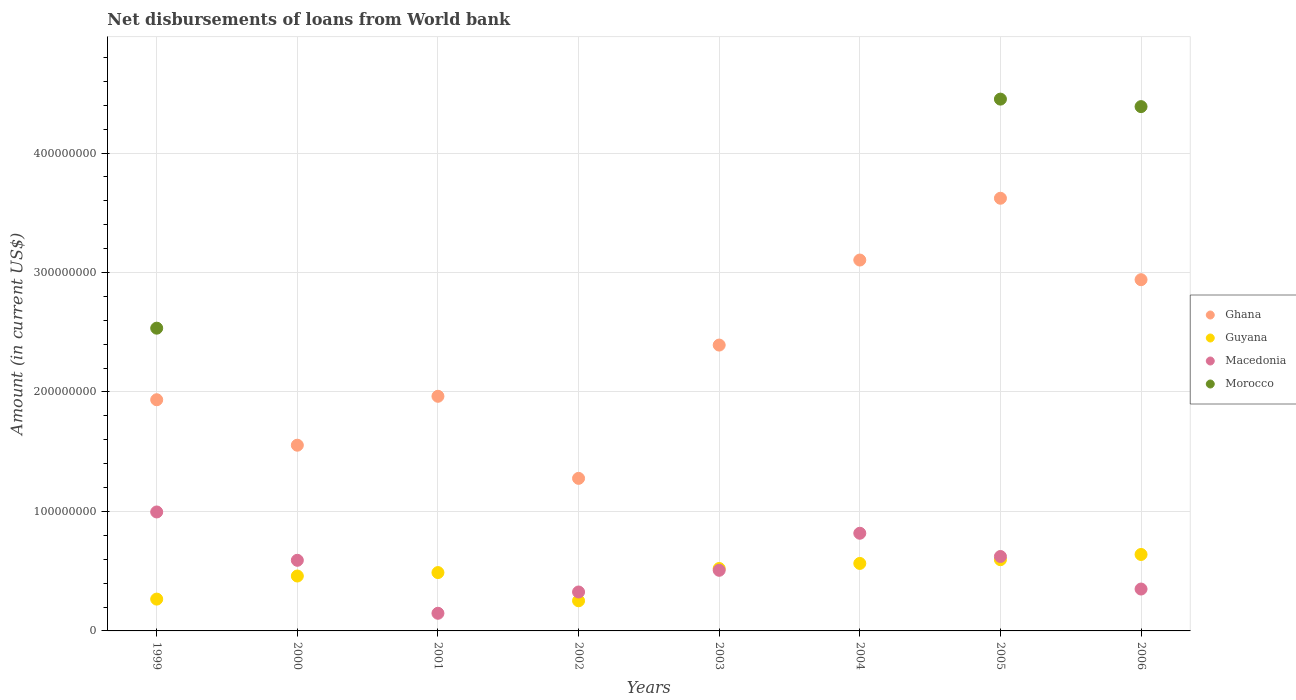How many different coloured dotlines are there?
Keep it short and to the point. 4. Is the number of dotlines equal to the number of legend labels?
Provide a short and direct response. No. What is the amount of loan disbursed from World Bank in Guyana in 2004?
Your answer should be compact. 5.65e+07. Across all years, what is the maximum amount of loan disbursed from World Bank in Morocco?
Give a very brief answer. 4.45e+08. What is the total amount of loan disbursed from World Bank in Morocco in the graph?
Ensure brevity in your answer.  1.14e+09. What is the difference between the amount of loan disbursed from World Bank in Guyana in 2000 and that in 2006?
Keep it short and to the point. -1.80e+07. What is the difference between the amount of loan disbursed from World Bank in Ghana in 2004 and the amount of loan disbursed from World Bank in Guyana in 2003?
Ensure brevity in your answer.  2.58e+08. What is the average amount of loan disbursed from World Bank in Macedonia per year?
Your response must be concise. 5.45e+07. In the year 2000, what is the difference between the amount of loan disbursed from World Bank in Macedonia and amount of loan disbursed from World Bank in Ghana?
Ensure brevity in your answer.  -9.63e+07. In how many years, is the amount of loan disbursed from World Bank in Guyana greater than 120000000 US$?
Keep it short and to the point. 0. What is the ratio of the amount of loan disbursed from World Bank in Guyana in 1999 to that in 2000?
Offer a terse response. 0.58. What is the difference between the highest and the second highest amount of loan disbursed from World Bank in Ghana?
Provide a short and direct response. 5.17e+07. What is the difference between the highest and the lowest amount of loan disbursed from World Bank in Macedonia?
Keep it short and to the point. 8.48e+07. In how many years, is the amount of loan disbursed from World Bank in Morocco greater than the average amount of loan disbursed from World Bank in Morocco taken over all years?
Your answer should be compact. 3. Is it the case that in every year, the sum of the amount of loan disbursed from World Bank in Guyana and amount of loan disbursed from World Bank in Morocco  is greater than the sum of amount of loan disbursed from World Bank in Ghana and amount of loan disbursed from World Bank in Macedonia?
Your answer should be very brief. No. Does the amount of loan disbursed from World Bank in Macedonia monotonically increase over the years?
Give a very brief answer. No. Is the amount of loan disbursed from World Bank in Ghana strictly less than the amount of loan disbursed from World Bank in Guyana over the years?
Your answer should be very brief. No. How many dotlines are there?
Offer a very short reply. 4. How many years are there in the graph?
Offer a terse response. 8. Does the graph contain grids?
Your answer should be very brief. Yes. Where does the legend appear in the graph?
Give a very brief answer. Center right. How many legend labels are there?
Offer a terse response. 4. How are the legend labels stacked?
Provide a short and direct response. Vertical. What is the title of the graph?
Your answer should be very brief. Net disbursements of loans from World bank. Does "Cote d'Ivoire" appear as one of the legend labels in the graph?
Give a very brief answer. No. What is the label or title of the Y-axis?
Your answer should be compact. Amount (in current US$). What is the Amount (in current US$) in Ghana in 1999?
Your response must be concise. 1.94e+08. What is the Amount (in current US$) in Guyana in 1999?
Your response must be concise. 2.66e+07. What is the Amount (in current US$) of Macedonia in 1999?
Ensure brevity in your answer.  9.96e+07. What is the Amount (in current US$) in Morocco in 1999?
Provide a succinct answer. 2.53e+08. What is the Amount (in current US$) of Ghana in 2000?
Give a very brief answer. 1.55e+08. What is the Amount (in current US$) of Guyana in 2000?
Provide a succinct answer. 4.60e+07. What is the Amount (in current US$) of Macedonia in 2000?
Keep it short and to the point. 5.91e+07. What is the Amount (in current US$) of Morocco in 2000?
Your response must be concise. 0. What is the Amount (in current US$) in Ghana in 2001?
Ensure brevity in your answer.  1.96e+08. What is the Amount (in current US$) of Guyana in 2001?
Make the answer very short. 4.88e+07. What is the Amount (in current US$) of Macedonia in 2001?
Your response must be concise. 1.48e+07. What is the Amount (in current US$) of Morocco in 2001?
Keep it short and to the point. 0. What is the Amount (in current US$) of Ghana in 2002?
Give a very brief answer. 1.28e+08. What is the Amount (in current US$) in Guyana in 2002?
Your answer should be compact. 2.52e+07. What is the Amount (in current US$) in Macedonia in 2002?
Your response must be concise. 3.26e+07. What is the Amount (in current US$) in Ghana in 2003?
Offer a terse response. 2.39e+08. What is the Amount (in current US$) of Guyana in 2003?
Provide a short and direct response. 5.22e+07. What is the Amount (in current US$) in Macedonia in 2003?
Your response must be concise. 5.07e+07. What is the Amount (in current US$) of Morocco in 2003?
Your answer should be very brief. 0. What is the Amount (in current US$) in Ghana in 2004?
Ensure brevity in your answer.  3.10e+08. What is the Amount (in current US$) in Guyana in 2004?
Offer a very short reply. 5.65e+07. What is the Amount (in current US$) in Macedonia in 2004?
Make the answer very short. 8.18e+07. What is the Amount (in current US$) of Ghana in 2005?
Provide a short and direct response. 3.62e+08. What is the Amount (in current US$) of Guyana in 2005?
Your answer should be very brief. 5.96e+07. What is the Amount (in current US$) in Macedonia in 2005?
Offer a very short reply. 6.23e+07. What is the Amount (in current US$) in Morocco in 2005?
Provide a short and direct response. 4.45e+08. What is the Amount (in current US$) in Ghana in 2006?
Your answer should be compact. 2.94e+08. What is the Amount (in current US$) in Guyana in 2006?
Your answer should be very brief. 6.40e+07. What is the Amount (in current US$) in Macedonia in 2006?
Make the answer very short. 3.51e+07. What is the Amount (in current US$) in Morocco in 2006?
Offer a very short reply. 4.39e+08. Across all years, what is the maximum Amount (in current US$) of Ghana?
Keep it short and to the point. 3.62e+08. Across all years, what is the maximum Amount (in current US$) of Guyana?
Offer a terse response. 6.40e+07. Across all years, what is the maximum Amount (in current US$) in Macedonia?
Offer a terse response. 9.96e+07. Across all years, what is the maximum Amount (in current US$) of Morocco?
Keep it short and to the point. 4.45e+08. Across all years, what is the minimum Amount (in current US$) in Ghana?
Offer a terse response. 1.28e+08. Across all years, what is the minimum Amount (in current US$) of Guyana?
Provide a succinct answer. 2.52e+07. Across all years, what is the minimum Amount (in current US$) in Macedonia?
Give a very brief answer. 1.48e+07. What is the total Amount (in current US$) of Ghana in the graph?
Your answer should be compact. 1.88e+09. What is the total Amount (in current US$) of Guyana in the graph?
Make the answer very short. 3.79e+08. What is the total Amount (in current US$) of Macedonia in the graph?
Your answer should be very brief. 4.36e+08. What is the total Amount (in current US$) in Morocco in the graph?
Give a very brief answer. 1.14e+09. What is the difference between the Amount (in current US$) of Ghana in 1999 and that in 2000?
Your answer should be very brief. 3.81e+07. What is the difference between the Amount (in current US$) of Guyana in 1999 and that in 2000?
Your answer should be compact. -1.93e+07. What is the difference between the Amount (in current US$) in Macedonia in 1999 and that in 2000?
Offer a terse response. 4.05e+07. What is the difference between the Amount (in current US$) in Ghana in 1999 and that in 2001?
Offer a terse response. -2.90e+06. What is the difference between the Amount (in current US$) of Guyana in 1999 and that in 2001?
Make the answer very short. -2.22e+07. What is the difference between the Amount (in current US$) of Macedonia in 1999 and that in 2001?
Give a very brief answer. 8.48e+07. What is the difference between the Amount (in current US$) in Ghana in 1999 and that in 2002?
Provide a succinct answer. 6.58e+07. What is the difference between the Amount (in current US$) in Guyana in 1999 and that in 2002?
Provide a short and direct response. 1.40e+06. What is the difference between the Amount (in current US$) in Macedonia in 1999 and that in 2002?
Provide a succinct answer. 6.70e+07. What is the difference between the Amount (in current US$) of Ghana in 1999 and that in 2003?
Make the answer very short. -4.58e+07. What is the difference between the Amount (in current US$) of Guyana in 1999 and that in 2003?
Give a very brief answer. -2.56e+07. What is the difference between the Amount (in current US$) of Macedonia in 1999 and that in 2003?
Your answer should be very brief. 4.88e+07. What is the difference between the Amount (in current US$) of Ghana in 1999 and that in 2004?
Make the answer very short. -1.17e+08. What is the difference between the Amount (in current US$) of Guyana in 1999 and that in 2004?
Offer a terse response. -2.99e+07. What is the difference between the Amount (in current US$) of Macedonia in 1999 and that in 2004?
Your answer should be very brief. 1.78e+07. What is the difference between the Amount (in current US$) in Ghana in 1999 and that in 2005?
Offer a very short reply. -1.69e+08. What is the difference between the Amount (in current US$) in Guyana in 1999 and that in 2005?
Give a very brief answer. -3.30e+07. What is the difference between the Amount (in current US$) in Macedonia in 1999 and that in 2005?
Your answer should be compact. 3.73e+07. What is the difference between the Amount (in current US$) of Morocco in 1999 and that in 2005?
Your answer should be very brief. -1.92e+08. What is the difference between the Amount (in current US$) of Ghana in 1999 and that in 2006?
Make the answer very short. -1.00e+08. What is the difference between the Amount (in current US$) in Guyana in 1999 and that in 2006?
Make the answer very short. -3.74e+07. What is the difference between the Amount (in current US$) of Macedonia in 1999 and that in 2006?
Ensure brevity in your answer.  6.45e+07. What is the difference between the Amount (in current US$) of Morocco in 1999 and that in 2006?
Ensure brevity in your answer.  -1.85e+08. What is the difference between the Amount (in current US$) in Ghana in 2000 and that in 2001?
Offer a very short reply. -4.09e+07. What is the difference between the Amount (in current US$) of Guyana in 2000 and that in 2001?
Make the answer very short. -2.88e+06. What is the difference between the Amount (in current US$) in Macedonia in 2000 and that in 2001?
Your response must be concise. 4.43e+07. What is the difference between the Amount (in current US$) in Ghana in 2000 and that in 2002?
Make the answer very short. 2.78e+07. What is the difference between the Amount (in current US$) in Guyana in 2000 and that in 2002?
Offer a very short reply. 2.07e+07. What is the difference between the Amount (in current US$) in Macedonia in 2000 and that in 2002?
Give a very brief answer. 2.65e+07. What is the difference between the Amount (in current US$) in Ghana in 2000 and that in 2003?
Ensure brevity in your answer.  -8.38e+07. What is the difference between the Amount (in current US$) of Guyana in 2000 and that in 2003?
Make the answer very short. -6.29e+06. What is the difference between the Amount (in current US$) of Macedonia in 2000 and that in 2003?
Offer a very short reply. 8.37e+06. What is the difference between the Amount (in current US$) of Ghana in 2000 and that in 2004?
Ensure brevity in your answer.  -1.55e+08. What is the difference between the Amount (in current US$) in Guyana in 2000 and that in 2004?
Give a very brief answer. -1.05e+07. What is the difference between the Amount (in current US$) in Macedonia in 2000 and that in 2004?
Offer a terse response. -2.26e+07. What is the difference between the Amount (in current US$) in Ghana in 2000 and that in 2005?
Give a very brief answer. -2.07e+08. What is the difference between the Amount (in current US$) of Guyana in 2000 and that in 2005?
Your response must be concise. -1.37e+07. What is the difference between the Amount (in current US$) of Macedonia in 2000 and that in 2005?
Your answer should be very brief. -3.19e+06. What is the difference between the Amount (in current US$) in Ghana in 2000 and that in 2006?
Give a very brief answer. -1.39e+08. What is the difference between the Amount (in current US$) of Guyana in 2000 and that in 2006?
Make the answer very short. -1.80e+07. What is the difference between the Amount (in current US$) in Macedonia in 2000 and that in 2006?
Your answer should be compact. 2.41e+07. What is the difference between the Amount (in current US$) in Ghana in 2001 and that in 2002?
Provide a short and direct response. 6.87e+07. What is the difference between the Amount (in current US$) of Guyana in 2001 and that in 2002?
Make the answer very short. 2.36e+07. What is the difference between the Amount (in current US$) in Macedonia in 2001 and that in 2002?
Offer a very short reply. -1.78e+07. What is the difference between the Amount (in current US$) of Ghana in 2001 and that in 2003?
Keep it short and to the point. -4.29e+07. What is the difference between the Amount (in current US$) in Guyana in 2001 and that in 2003?
Your answer should be compact. -3.41e+06. What is the difference between the Amount (in current US$) in Macedonia in 2001 and that in 2003?
Your answer should be compact. -3.60e+07. What is the difference between the Amount (in current US$) of Ghana in 2001 and that in 2004?
Ensure brevity in your answer.  -1.14e+08. What is the difference between the Amount (in current US$) in Guyana in 2001 and that in 2004?
Offer a terse response. -7.65e+06. What is the difference between the Amount (in current US$) in Macedonia in 2001 and that in 2004?
Provide a short and direct response. -6.70e+07. What is the difference between the Amount (in current US$) of Ghana in 2001 and that in 2005?
Your answer should be very brief. -1.66e+08. What is the difference between the Amount (in current US$) of Guyana in 2001 and that in 2005?
Give a very brief answer. -1.08e+07. What is the difference between the Amount (in current US$) in Macedonia in 2001 and that in 2005?
Keep it short and to the point. -4.75e+07. What is the difference between the Amount (in current US$) of Ghana in 2001 and that in 2006?
Offer a very short reply. -9.76e+07. What is the difference between the Amount (in current US$) in Guyana in 2001 and that in 2006?
Your response must be concise. -1.52e+07. What is the difference between the Amount (in current US$) of Macedonia in 2001 and that in 2006?
Your answer should be compact. -2.03e+07. What is the difference between the Amount (in current US$) in Ghana in 2002 and that in 2003?
Offer a very short reply. -1.12e+08. What is the difference between the Amount (in current US$) in Guyana in 2002 and that in 2003?
Give a very brief answer. -2.70e+07. What is the difference between the Amount (in current US$) in Macedonia in 2002 and that in 2003?
Your answer should be compact. -1.82e+07. What is the difference between the Amount (in current US$) in Ghana in 2002 and that in 2004?
Make the answer very short. -1.83e+08. What is the difference between the Amount (in current US$) of Guyana in 2002 and that in 2004?
Give a very brief answer. -3.13e+07. What is the difference between the Amount (in current US$) in Macedonia in 2002 and that in 2004?
Ensure brevity in your answer.  -4.92e+07. What is the difference between the Amount (in current US$) in Ghana in 2002 and that in 2005?
Your answer should be compact. -2.34e+08. What is the difference between the Amount (in current US$) in Guyana in 2002 and that in 2005?
Provide a succinct answer. -3.44e+07. What is the difference between the Amount (in current US$) in Macedonia in 2002 and that in 2005?
Provide a short and direct response. -2.97e+07. What is the difference between the Amount (in current US$) in Ghana in 2002 and that in 2006?
Your answer should be compact. -1.66e+08. What is the difference between the Amount (in current US$) of Guyana in 2002 and that in 2006?
Your response must be concise. -3.88e+07. What is the difference between the Amount (in current US$) in Macedonia in 2002 and that in 2006?
Make the answer very short. -2.47e+06. What is the difference between the Amount (in current US$) of Ghana in 2003 and that in 2004?
Provide a short and direct response. -7.12e+07. What is the difference between the Amount (in current US$) in Guyana in 2003 and that in 2004?
Your answer should be very brief. -4.25e+06. What is the difference between the Amount (in current US$) of Macedonia in 2003 and that in 2004?
Provide a succinct answer. -3.10e+07. What is the difference between the Amount (in current US$) in Ghana in 2003 and that in 2005?
Keep it short and to the point. -1.23e+08. What is the difference between the Amount (in current US$) in Guyana in 2003 and that in 2005?
Ensure brevity in your answer.  -7.37e+06. What is the difference between the Amount (in current US$) in Macedonia in 2003 and that in 2005?
Offer a terse response. -1.16e+07. What is the difference between the Amount (in current US$) in Ghana in 2003 and that in 2006?
Ensure brevity in your answer.  -5.47e+07. What is the difference between the Amount (in current US$) of Guyana in 2003 and that in 2006?
Provide a succinct answer. -1.17e+07. What is the difference between the Amount (in current US$) in Macedonia in 2003 and that in 2006?
Your answer should be compact. 1.57e+07. What is the difference between the Amount (in current US$) of Ghana in 2004 and that in 2005?
Your response must be concise. -5.17e+07. What is the difference between the Amount (in current US$) in Guyana in 2004 and that in 2005?
Offer a very short reply. -3.12e+06. What is the difference between the Amount (in current US$) of Macedonia in 2004 and that in 2005?
Provide a short and direct response. 1.94e+07. What is the difference between the Amount (in current US$) in Ghana in 2004 and that in 2006?
Give a very brief answer. 1.64e+07. What is the difference between the Amount (in current US$) of Guyana in 2004 and that in 2006?
Give a very brief answer. -7.50e+06. What is the difference between the Amount (in current US$) in Macedonia in 2004 and that in 2006?
Ensure brevity in your answer.  4.67e+07. What is the difference between the Amount (in current US$) in Ghana in 2005 and that in 2006?
Provide a short and direct response. 6.82e+07. What is the difference between the Amount (in current US$) of Guyana in 2005 and that in 2006?
Keep it short and to the point. -4.38e+06. What is the difference between the Amount (in current US$) in Macedonia in 2005 and that in 2006?
Keep it short and to the point. 2.72e+07. What is the difference between the Amount (in current US$) of Morocco in 2005 and that in 2006?
Offer a terse response. 6.27e+06. What is the difference between the Amount (in current US$) of Ghana in 1999 and the Amount (in current US$) of Guyana in 2000?
Your answer should be compact. 1.48e+08. What is the difference between the Amount (in current US$) of Ghana in 1999 and the Amount (in current US$) of Macedonia in 2000?
Give a very brief answer. 1.34e+08. What is the difference between the Amount (in current US$) in Guyana in 1999 and the Amount (in current US$) in Macedonia in 2000?
Give a very brief answer. -3.25e+07. What is the difference between the Amount (in current US$) of Ghana in 1999 and the Amount (in current US$) of Guyana in 2001?
Your answer should be very brief. 1.45e+08. What is the difference between the Amount (in current US$) in Ghana in 1999 and the Amount (in current US$) in Macedonia in 2001?
Your answer should be very brief. 1.79e+08. What is the difference between the Amount (in current US$) of Guyana in 1999 and the Amount (in current US$) of Macedonia in 2001?
Offer a terse response. 1.19e+07. What is the difference between the Amount (in current US$) of Ghana in 1999 and the Amount (in current US$) of Guyana in 2002?
Make the answer very short. 1.68e+08. What is the difference between the Amount (in current US$) of Ghana in 1999 and the Amount (in current US$) of Macedonia in 2002?
Your answer should be compact. 1.61e+08. What is the difference between the Amount (in current US$) of Guyana in 1999 and the Amount (in current US$) of Macedonia in 2002?
Your response must be concise. -5.96e+06. What is the difference between the Amount (in current US$) in Ghana in 1999 and the Amount (in current US$) in Guyana in 2003?
Provide a succinct answer. 1.41e+08. What is the difference between the Amount (in current US$) of Ghana in 1999 and the Amount (in current US$) of Macedonia in 2003?
Provide a succinct answer. 1.43e+08. What is the difference between the Amount (in current US$) in Guyana in 1999 and the Amount (in current US$) in Macedonia in 2003?
Give a very brief answer. -2.41e+07. What is the difference between the Amount (in current US$) of Ghana in 1999 and the Amount (in current US$) of Guyana in 2004?
Provide a succinct answer. 1.37e+08. What is the difference between the Amount (in current US$) of Ghana in 1999 and the Amount (in current US$) of Macedonia in 2004?
Make the answer very short. 1.12e+08. What is the difference between the Amount (in current US$) in Guyana in 1999 and the Amount (in current US$) in Macedonia in 2004?
Provide a succinct answer. -5.51e+07. What is the difference between the Amount (in current US$) of Ghana in 1999 and the Amount (in current US$) of Guyana in 2005?
Provide a succinct answer. 1.34e+08. What is the difference between the Amount (in current US$) of Ghana in 1999 and the Amount (in current US$) of Macedonia in 2005?
Ensure brevity in your answer.  1.31e+08. What is the difference between the Amount (in current US$) of Ghana in 1999 and the Amount (in current US$) of Morocco in 2005?
Provide a succinct answer. -2.52e+08. What is the difference between the Amount (in current US$) of Guyana in 1999 and the Amount (in current US$) of Macedonia in 2005?
Ensure brevity in your answer.  -3.57e+07. What is the difference between the Amount (in current US$) of Guyana in 1999 and the Amount (in current US$) of Morocco in 2005?
Ensure brevity in your answer.  -4.19e+08. What is the difference between the Amount (in current US$) in Macedonia in 1999 and the Amount (in current US$) in Morocco in 2005?
Keep it short and to the point. -3.46e+08. What is the difference between the Amount (in current US$) of Ghana in 1999 and the Amount (in current US$) of Guyana in 2006?
Your answer should be compact. 1.30e+08. What is the difference between the Amount (in current US$) in Ghana in 1999 and the Amount (in current US$) in Macedonia in 2006?
Ensure brevity in your answer.  1.58e+08. What is the difference between the Amount (in current US$) of Ghana in 1999 and the Amount (in current US$) of Morocco in 2006?
Your answer should be compact. -2.45e+08. What is the difference between the Amount (in current US$) in Guyana in 1999 and the Amount (in current US$) in Macedonia in 2006?
Give a very brief answer. -8.43e+06. What is the difference between the Amount (in current US$) in Guyana in 1999 and the Amount (in current US$) in Morocco in 2006?
Your answer should be very brief. -4.12e+08. What is the difference between the Amount (in current US$) of Macedonia in 1999 and the Amount (in current US$) of Morocco in 2006?
Make the answer very short. -3.39e+08. What is the difference between the Amount (in current US$) in Ghana in 2000 and the Amount (in current US$) in Guyana in 2001?
Provide a short and direct response. 1.07e+08. What is the difference between the Amount (in current US$) in Ghana in 2000 and the Amount (in current US$) in Macedonia in 2001?
Keep it short and to the point. 1.41e+08. What is the difference between the Amount (in current US$) in Guyana in 2000 and the Amount (in current US$) in Macedonia in 2001?
Provide a succinct answer. 3.12e+07. What is the difference between the Amount (in current US$) in Ghana in 2000 and the Amount (in current US$) in Guyana in 2002?
Your answer should be compact. 1.30e+08. What is the difference between the Amount (in current US$) of Ghana in 2000 and the Amount (in current US$) of Macedonia in 2002?
Make the answer very short. 1.23e+08. What is the difference between the Amount (in current US$) of Guyana in 2000 and the Amount (in current US$) of Macedonia in 2002?
Keep it short and to the point. 1.34e+07. What is the difference between the Amount (in current US$) of Ghana in 2000 and the Amount (in current US$) of Guyana in 2003?
Offer a very short reply. 1.03e+08. What is the difference between the Amount (in current US$) of Ghana in 2000 and the Amount (in current US$) of Macedonia in 2003?
Your answer should be very brief. 1.05e+08. What is the difference between the Amount (in current US$) in Guyana in 2000 and the Amount (in current US$) in Macedonia in 2003?
Your answer should be compact. -4.79e+06. What is the difference between the Amount (in current US$) of Ghana in 2000 and the Amount (in current US$) of Guyana in 2004?
Offer a terse response. 9.90e+07. What is the difference between the Amount (in current US$) of Ghana in 2000 and the Amount (in current US$) of Macedonia in 2004?
Give a very brief answer. 7.37e+07. What is the difference between the Amount (in current US$) in Guyana in 2000 and the Amount (in current US$) in Macedonia in 2004?
Make the answer very short. -3.58e+07. What is the difference between the Amount (in current US$) in Ghana in 2000 and the Amount (in current US$) in Guyana in 2005?
Your answer should be very brief. 9.58e+07. What is the difference between the Amount (in current US$) of Ghana in 2000 and the Amount (in current US$) of Macedonia in 2005?
Offer a very short reply. 9.32e+07. What is the difference between the Amount (in current US$) of Ghana in 2000 and the Amount (in current US$) of Morocco in 2005?
Offer a very short reply. -2.90e+08. What is the difference between the Amount (in current US$) in Guyana in 2000 and the Amount (in current US$) in Macedonia in 2005?
Your response must be concise. -1.63e+07. What is the difference between the Amount (in current US$) of Guyana in 2000 and the Amount (in current US$) of Morocco in 2005?
Offer a very short reply. -3.99e+08. What is the difference between the Amount (in current US$) of Macedonia in 2000 and the Amount (in current US$) of Morocco in 2005?
Your answer should be very brief. -3.86e+08. What is the difference between the Amount (in current US$) in Ghana in 2000 and the Amount (in current US$) in Guyana in 2006?
Your answer should be compact. 9.15e+07. What is the difference between the Amount (in current US$) in Ghana in 2000 and the Amount (in current US$) in Macedonia in 2006?
Give a very brief answer. 1.20e+08. What is the difference between the Amount (in current US$) of Ghana in 2000 and the Amount (in current US$) of Morocco in 2006?
Keep it short and to the point. -2.83e+08. What is the difference between the Amount (in current US$) in Guyana in 2000 and the Amount (in current US$) in Macedonia in 2006?
Keep it short and to the point. 1.09e+07. What is the difference between the Amount (in current US$) in Guyana in 2000 and the Amount (in current US$) in Morocco in 2006?
Your response must be concise. -3.93e+08. What is the difference between the Amount (in current US$) in Macedonia in 2000 and the Amount (in current US$) in Morocco in 2006?
Your answer should be very brief. -3.80e+08. What is the difference between the Amount (in current US$) of Ghana in 2001 and the Amount (in current US$) of Guyana in 2002?
Your answer should be very brief. 1.71e+08. What is the difference between the Amount (in current US$) of Ghana in 2001 and the Amount (in current US$) of Macedonia in 2002?
Your answer should be very brief. 1.64e+08. What is the difference between the Amount (in current US$) of Guyana in 2001 and the Amount (in current US$) of Macedonia in 2002?
Ensure brevity in your answer.  1.63e+07. What is the difference between the Amount (in current US$) of Ghana in 2001 and the Amount (in current US$) of Guyana in 2003?
Your response must be concise. 1.44e+08. What is the difference between the Amount (in current US$) in Ghana in 2001 and the Amount (in current US$) in Macedonia in 2003?
Provide a short and direct response. 1.46e+08. What is the difference between the Amount (in current US$) of Guyana in 2001 and the Amount (in current US$) of Macedonia in 2003?
Offer a terse response. -1.91e+06. What is the difference between the Amount (in current US$) in Ghana in 2001 and the Amount (in current US$) in Guyana in 2004?
Provide a short and direct response. 1.40e+08. What is the difference between the Amount (in current US$) in Ghana in 2001 and the Amount (in current US$) in Macedonia in 2004?
Provide a succinct answer. 1.15e+08. What is the difference between the Amount (in current US$) in Guyana in 2001 and the Amount (in current US$) in Macedonia in 2004?
Provide a succinct answer. -3.29e+07. What is the difference between the Amount (in current US$) of Ghana in 2001 and the Amount (in current US$) of Guyana in 2005?
Offer a very short reply. 1.37e+08. What is the difference between the Amount (in current US$) in Ghana in 2001 and the Amount (in current US$) in Macedonia in 2005?
Give a very brief answer. 1.34e+08. What is the difference between the Amount (in current US$) in Ghana in 2001 and the Amount (in current US$) in Morocco in 2005?
Provide a short and direct response. -2.49e+08. What is the difference between the Amount (in current US$) in Guyana in 2001 and the Amount (in current US$) in Macedonia in 2005?
Offer a very short reply. -1.35e+07. What is the difference between the Amount (in current US$) of Guyana in 2001 and the Amount (in current US$) of Morocco in 2005?
Keep it short and to the point. -3.96e+08. What is the difference between the Amount (in current US$) of Macedonia in 2001 and the Amount (in current US$) of Morocco in 2005?
Provide a short and direct response. -4.30e+08. What is the difference between the Amount (in current US$) of Ghana in 2001 and the Amount (in current US$) of Guyana in 2006?
Your answer should be very brief. 1.32e+08. What is the difference between the Amount (in current US$) of Ghana in 2001 and the Amount (in current US$) of Macedonia in 2006?
Keep it short and to the point. 1.61e+08. What is the difference between the Amount (in current US$) of Ghana in 2001 and the Amount (in current US$) of Morocco in 2006?
Your answer should be very brief. -2.42e+08. What is the difference between the Amount (in current US$) of Guyana in 2001 and the Amount (in current US$) of Macedonia in 2006?
Offer a terse response. 1.38e+07. What is the difference between the Amount (in current US$) in Guyana in 2001 and the Amount (in current US$) in Morocco in 2006?
Your answer should be very brief. -3.90e+08. What is the difference between the Amount (in current US$) of Macedonia in 2001 and the Amount (in current US$) of Morocco in 2006?
Offer a terse response. -4.24e+08. What is the difference between the Amount (in current US$) in Ghana in 2002 and the Amount (in current US$) in Guyana in 2003?
Give a very brief answer. 7.55e+07. What is the difference between the Amount (in current US$) in Ghana in 2002 and the Amount (in current US$) in Macedonia in 2003?
Your answer should be very brief. 7.70e+07. What is the difference between the Amount (in current US$) of Guyana in 2002 and the Amount (in current US$) of Macedonia in 2003?
Your response must be concise. -2.55e+07. What is the difference between the Amount (in current US$) of Ghana in 2002 and the Amount (in current US$) of Guyana in 2004?
Keep it short and to the point. 7.12e+07. What is the difference between the Amount (in current US$) of Ghana in 2002 and the Amount (in current US$) of Macedonia in 2004?
Your answer should be very brief. 4.60e+07. What is the difference between the Amount (in current US$) in Guyana in 2002 and the Amount (in current US$) in Macedonia in 2004?
Ensure brevity in your answer.  -5.65e+07. What is the difference between the Amount (in current US$) in Ghana in 2002 and the Amount (in current US$) in Guyana in 2005?
Your answer should be compact. 6.81e+07. What is the difference between the Amount (in current US$) in Ghana in 2002 and the Amount (in current US$) in Macedonia in 2005?
Your response must be concise. 6.54e+07. What is the difference between the Amount (in current US$) in Ghana in 2002 and the Amount (in current US$) in Morocco in 2005?
Keep it short and to the point. -3.17e+08. What is the difference between the Amount (in current US$) in Guyana in 2002 and the Amount (in current US$) in Macedonia in 2005?
Ensure brevity in your answer.  -3.71e+07. What is the difference between the Amount (in current US$) in Guyana in 2002 and the Amount (in current US$) in Morocco in 2005?
Provide a succinct answer. -4.20e+08. What is the difference between the Amount (in current US$) of Macedonia in 2002 and the Amount (in current US$) of Morocco in 2005?
Offer a very short reply. -4.13e+08. What is the difference between the Amount (in current US$) of Ghana in 2002 and the Amount (in current US$) of Guyana in 2006?
Your response must be concise. 6.37e+07. What is the difference between the Amount (in current US$) of Ghana in 2002 and the Amount (in current US$) of Macedonia in 2006?
Give a very brief answer. 9.26e+07. What is the difference between the Amount (in current US$) of Ghana in 2002 and the Amount (in current US$) of Morocco in 2006?
Offer a terse response. -3.11e+08. What is the difference between the Amount (in current US$) in Guyana in 2002 and the Amount (in current US$) in Macedonia in 2006?
Your response must be concise. -9.83e+06. What is the difference between the Amount (in current US$) in Guyana in 2002 and the Amount (in current US$) in Morocco in 2006?
Keep it short and to the point. -4.14e+08. What is the difference between the Amount (in current US$) of Macedonia in 2002 and the Amount (in current US$) of Morocco in 2006?
Your answer should be very brief. -4.06e+08. What is the difference between the Amount (in current US$) of Ghana in 2003 and the Amount (in current US$) of Guyana in 2004?
Provide a short and direct response. 1.83e+08. What is the difference between the Amount (in current US$) of Ghana in 2003 and the Amount (in current US$) of Macedonia in 2004?
Give a very brief answer. 1.58e+08. What is the difference between the Amount (in current US$) in Guyana in 2003 and the Amount (in current US$) in Macedonia in 2004?
Your answer should be very brief. -2.95e+07. What is the difference between the Amount (in current US$) in Ghana in 2003 and the Amount (in current US$) in Guyana in 2005?
Your answer should be very brief. 1.80e+08. What is the difference between the Amount (in current US$) in Ghana in 2003 and the Amount (in current US$) in Macedonia in 2005?
Give a very brief answer. 1.77e+08. What is the difference between the Amount (in current US$) in Ghana in 2003 and the Amount (in current US$) in Morocco in 2005?
Offer a terse response. -2.06e+08. What is the difference between the Amount (in current US$) in Guyana in 2003 and the Amount (in current US$) in Macedonia in 2005?
Your response must be concise. -1.01e+07. What is the difference between the Amount (in current US$) of Guyana in 2003 and the Amount (in current US$) of Morocco in 2005?
Offer a very short reply. -3.93e+08. What is the difference between the Amount (in current US$) in Macedonia in 2003 and the Amount (in current US$) in Morocco in 2005?
Ensure brevity in your answer.  -3.94e+08. What is the difference between the Amount (in current US$) in Ghana in 2003 and the Amount (in current US$) in Guyana in 2006?
Offer a very short reply. 1.75e+08. What is the difference between the Amount (in current US$) of Ghana in 2003 and the Amount (in current US$) of Macedonia in 2006?
Ensure brevity in your answer.  2.04e+08. What is the difference between the Amount (in current US$) in Ghana in 2003 and the Amount (in current US$) in Morocco in 2006?
Give a very brief answer. -2.00e+08. What is the difference between the Amount (in current US$) in Guyana in 2003 and the Amount (in current US$) in Macedonia in 2006?
Offer a very short reply. 1.72e+07. What is the difference between the Amount (in current US$) of Guyana in 2003 and the Amount (in current US$) of Morocco in 2006?
Your response must be concise. -3.87e+08. What is the difference between the Amount (in current US$) in Macedonia in 2003 and the Amount (in current US$) in Morocco in 2006?
Your answer should be compact. -3.88e+08. What is the difference between the Amount (in current US$) in Ghana in 2004 and the Amount (in current US$) in Guyana in 2005?
Ensure brevity in your answer.  2.51e+08. What is the difference between the Amount (in current US$) of Ghana in 2004 and the Amount (in current US$) of Macedonia in 2005?
Keep it short and to the point. 2.48e+08. What is the difference between the Amount (in current US$) in Ghana in 2004 and the Amount (in current US$) in Morocco in 2005?
Your answer should be very brief. -1.35e+08. What is the difference between the Amount (in current US$) in Guyana in 2004 and the Amount (in current US$) in Macedonia in 2005?
Offer a terse response. -5.81e+06. What is the difference between the Amount (in current US$) in Guyana in 2004 and the Amount (in current US$) in Morocco in 2005?
Provide a short and direct response. -3.89e+08. What is the difference between the Amount (in current US$) in Macedonia in 2004 and the Amount (in current US$) in Morocco in 2005?
Give a very brief answer. -3.63e+08. What is the difference between the Amount (in current US$) of Ghana in 2004 and the Amount (in current US$) of Guyana in 2006?
Provide a succinct answer. 2.46e+08. What is the difference between the Amount (in current US$) in Ghana in 2004 and the Amount (in current US$) in Macedonia in 2006?
Your answer should be very brief. 2.75e+08. What is the difference between the Amount (in current US$) in Ghana in 2004 and the Amount (in current US$) in Morocco in 2006?
Give a very brief answer. -1.28e+08. What is the difference between the Amount (in current US$) in Guyana in 2004 and the Amount (in current US$) in Macedonia in 2006?
Provide a succinct answer. 2.14e+07. What is the difference between the Amount (in current US$) of Guyana in 2004 and the Amount (in current US$) of Morocco in 2006?
Offer a very short reply. -3.82e+08. What is the difference between the Amount (in current US$) of Macedonia in 2004 and the Amount (in current US$) of Morocco in 2006?
Your answer should be very brief. -3.57e+08. What is the difference between the Amount (in current US$) in Ghana in 2005 and the Amount (in current US$) in Guyana in 2006?
Your answer should be very brief. 2.98e+08. What is the difference between the Amount (in current US$) of Ghana in 2005 and the Amount (in current US$) of Macedonia in 2006?
Ensure brevity in your answer.  3.27e+08. What is the difference between the Amount (in current US$) of Ghana in 2005 and the Amount (in current US$) of Morocco in 2006?
Provide a succinct answer. -7.67e+07. What is the difference between the Amount (in current US$) of Guyana in 2005 and the Amount (in current US$) of Macedonia in 2006?
Offer a terse response. 2.46e+07. What is the difference between the Amount (in current US$) of Guyana in 2005 and the Amount (in current US$) of Morocco in 2006?
Provide a succinct answer. -3.79e+08. What is the difference between the Amount (in current US$) in Macedonia in 2005 and the Amount (in current US$) in Morocco in 2006?
Your answer should be very brief. -3.77e+08. What is the average Amount (in current US$) of Ghana per year?
Make the answer very short. 2.35e+08. What is the average Amount (in current US$) in Guyana per year?
Provide a succinct answer. 4.74e+07. What is the average Amount (in current US$) in Macedonia per year?
Make the answer very short. 5.45e+07. What is the average Amount (in current US$) of Morocco per year?
Offer a terse response. 1.42e+08. In the year 1999, what is the difference between the Amount (in current US$) in Ghana and Amount (in current US$) in Guyana?
Provide a short and direct response. 1.67e+08. In the year 1999, what is the difference between the Amount (in current US$) of Ghana and Amount (in current US$) of Macedonia?
Make the answer very short. 9.39e+07. In the year 1999, what is the difference between the Amount (in current US$) of Ghana and Amount (in current US$) of Morocco?
Your response must be concise. -5.99e+07. In the year 1999, what is the difference between the Amount (in current US$) of Guyana and Amount (in current US$) of Macedonia?
Your answer should be very brief. -7.29e+07. In the year 1999, what is the difference between the Amount (in current US$) of Guyana and Amount (in current US$) of Morocco?
Offer a very short reply. -2.27e+08. In the year 1999, what is the difference between the Amount (in current US$) in Macedonia and Amount (in current US$) in Morocco?
Provide a short and direct response. -1.54e+08. In the year 2000, what is the difference between the Amount (in current US$) of Ghana and Amount (in current US$) of Guyana?
Your answer should be compact. 1.10e+08. In the year 2000, what is the difference between the Amount (in current US$) of Ghana and Amount (in current US$) of Macedonia?
Your answer should be compact. 9.63e+07. In the year 2000, what is the difference between the Amount (in current US$) in Guyana and Amount (in current US$) in Macedonia?
Your response must be concise. -1.32e+07. In the year 2001, what is the difference between the Amount (in current US$) in Ghana and Amount (in current US$) in Guyana?
Provide a succinct answer. 1.48e+08. In the year 2001, what is the difference between the Amount (in current US$) of Ghana and Amount (in current US$) of Macedonia?
Give a very brief answer. 1.82e+08. In the year 2001, what is the difference between the Amount (in current US$) in Guyana and Amount (in current US$) in Macedonia?
Provide a succinct answer. 3.41e+07. In the year 2002, what is the difference between the Amount (in current US$) of Ghana and Amount (in current US$) of Guyana?
Offer a terse response. 1.02e+08. In the year 2002, what is the difference between the Amount (in current US$) in Ghana and Amount (in current US$) in Macedonia?
Provide a succinct answer. 9.51e+07. In the year 2002, what is the difference between the Amount (in current US$) of Guyana and Amount (in current US$) of Macedonia?
Ensure brevity in your answer.  -7.36e+06. In the year 2003, what is the difference between the Amount (in current US$) in Ghana and Amount (in current US$) in Guyana?
Give a very brief answer. 1.87e+08. In the year 2003, what is the difference between the Amount (in current US$) of Ghana and Amount (in current US$) of Macedonia?
Your answer should be very brief. 1.89e+08. In the year 2003, what is the difference between the Amount (in current US$) in Guyana and Amount (in current US$) in Macedonia?
Provide a succinct answer. 1.50e+06. In the year 2004, what is the difference between the Amount (in current US$) of Ghana and Amount (in current US$) of Guyana?
Your response must be concise. 2.54e+08. In the year 2004, what is the difference between the Amount (in current US$) in Ghana and Amount (in current US$) in Macedonia?
Give a very brief answer. 2.29e+08. In the year 2004, what is the difference between the Amount (in current US$) of Guyana and Amount (in current US$) of Macedonia?
Keep it short and to the point. -2.53e+07. In the year 2005, what is the difference between the Amount (in current US$) in Ghana and Amount (in current US$) in Guyana?
Your answer should be very brief. 3.03e+08. In the year 2005, what is the difference between the Amount (in current US$) of Ghana and Amount (in current US$) of Macedonia?
Provide a short and direct response. 3.00e+08. In the year 2005, what is the difference between the Amount (in current US$) in Ghana and Amount (in current US$) in Morocco?
Give a very brief answer. -8.30e+07. In the year 2005, what is the difference between the Amount (in current US$) in Guyana and Amount (in current US$) in Macedonia?
Give a very brief answer. -2.69e+06. In the year 2005, what is the difference between the Amount (in current US$) in Guyana and Amount (in current US$) in Morocco?
Keep it short and to the point. -3.86e+08. In the year 2005, what is the difference between the Amount (in current US$) of Macedonia and Amount (in current US$) of Morocco?
Offer a very short reply. -3.83e+08. In the year 2006, what is the difference between the Amount (in current US$) in Ghana and Amount (in current US$) in Guyana?
Give a very brief answer. 2.30e+08. In the year 2006, what is the difference between the Amount (in current US$) of Ghana and Amount (in current US$) of Macedonia?
Offer a very short reply. 2.59e+08. In the year 2006, what is the difference between the Amount (in current US$) in Ghana and Amount (in current US$) in Morocco?
Keep it short and to the point. -1.45e+08. In the year 2006, what is the difference between the Amount (in current US$) in Guyana and Amount (in current US$) in Macedonia?
Ensure brevity in your answer.  2.89e+07. In the year 2006, what is the difference between the Amount (in current US$) of Guyana and Amount (in current US$) of Morocco?
Your response must be concise. -3.75e+08. In the year 2006, what is the difference between the Amount (in current US$) of Macedonia and Amount (in current US$) of Morocco?
Give a very brief answer. -4.04e+08. What is the ratio of the Amount (in current US$) in Ghana in 1999 to that in 2000?
Your response must be concise. 1.24. What is the ratio of the Amount (in current US$) of Guyana in 1999 to that in 2000?
Your response must be concise. 0.58. What is the ratio of the Amount (in current US$) of Macedonia in 1999 to that in 2000?
Ensure brevity in your answer.  1.68. What is the ratio of the Amount (in current US$) of Guyana in 1999 to that in 2001?
Ensure brevity in your answer.  0.55. What is the ratio of the Amount (in current US$) in Macedonia in 1999 to that in 2001?
Give a very brief answer. 6.74. What is the ratio of the Amount (in current US$) of Ghana in 1999 to that in 2002?
Make the answer very short. 1.52. What is the ratio of the Amount (in current US$) of Guyana in 1999 to that in 2002?
Make the answer very short. 1.06. What is the ratio of the Amount (in current US$) in Macedonia in 1999 to that in 2002?
Your answer should be very brief. 3.06. What is the ratio of the Amount (in current US$) of Ghana in 1999 to that in 2003?
Make the answer very short. 0.81. What is the ratio of the Amount (in current US$) in Guyana in 1999 to that in 2003?
Ensure brevity in your answer.  0.51. What is the ratio of the Amount (in current US$) in Macedonia in 1999 to that in 2003?
Keep it short and to the point. 1.96. What is the ratio of the Amount (in current US$) of Ghana in 1999 to that in 2004?
Provide a short and direct response. 0.62. What is the ratio of the Amount (in current US$) of Guyana in 1999 to that in 2004?
Provide a succinct answer. 0.47. What is the ratio of the Amount (in current US$) in Macedonia in 1999 to that in 2004?
Provide a short and direct response. 1.22. What is the ratio of the Amount (in current US$) in Ghana in 1999 to that in 2005?
Give a very brief answer. 0.53. What is the ratio of the Amount (in current US$) in Guyana in 1999 to that in 2005?
Your answer should be very brief. 0.45. What is the ratio of the Amount (in current US$) in Macedonia in 1999 to that in 2005?
Your answer should be compact. 1.6. What is the ratio of the Amount (in current US$) of Morocco in 1999 to that in 2005?
Ensure brevity in your answer.  0.57. What is the ratio of the Amount (in current US$) in Ghana in 1999 to that in 2006?
Provide a short and direct response. 0.66. What is the ratio of the Amount (in current US$) in Guyana in 1999 to that in 2006?
Your answer should be compact. 0.42. What is the ratio of the Amount (in current US$) of Macedonia in 1999 to that in 2006?
Provide a succinct answer. 2.84. What is the ratio of the Amount (in current US$) of Morocco in 1999 to that in 2006?
Your answer should be very brief. 0.58. What is the ratio of the Amount (in current US$) of Ghana in 2000 to that in 2001?
Your answer should be very brief. 0.79. What is the ratio of the Amount (in current US$) in Guyana in 2000 to that in 2001?
Keep it short and to the point. 0.94. What is the ratio of the Amount (in current US$) of Macedonia in 2000 to that in 2001?
Make the answer very short. 4. What is the ratio of the Amount (in current US$) in Ghana in 2000 to that in 2002?
Offer a terse response. 1.22. What is the ratio of the Amount (in current US$) of Guyana in 2000 to that in 2002?
Offer a very short reply. 1.82. What is the ratio of the Amount (in current US$) in Macedonia in 2000 to that in 2002?
Ensure brevity in your answer.  1.81. What is the ratio of the Amount (in current US$) in Ghana in 2000 to that in 2003?
Make the answer very short. 0.65. What is the ratio of the Amount (in current US$) of Guyana in 2000 to that in 2003?
Your answer should be very brief. 0.88. What is the ratio of the Amount (in current US$) of Macedonia in 2000 to that in 2003?
Provide a succinct answer. 1.16. What is the ratio of the Amount (in current US$) of Ghana in 2000 to that in 2004?
Keep it short and to the point. 0.5. What is the ratio of the Amount (in current US$) in Guyana in 2000 to that in 2004?
Make the answer very short. 0.81. What is the ratio of the Amount (in current US$) in Macedonia in 2000 to that in 2004?
Offer a terse response. 0.72. What is the ratio of the Amount (in current US$) of Ghana in 2000 to that in 2005?
Your answer should be very brief. 0.43. What is the ratio of the Amount (in current US$) in Guyana in 2000 to that in 2005?
Give a very brief answer. 0.77. What is the ratio of the Amount (in current US$) in Macedonia in 2000 to that in 2005?
Your answer should be compact. 0.95. What is the ratio of the Amount (in current US$) of Ghana in 2000 to that in 2006?
Your response must be concise. 0.53. What is the ratio of the Amount (in current US$) in Guyana in 2000 to that in 2006?
Your answer should be compact. 0.72. What is the ratio of the Amount (in current US$) in Macedonia in 2000 to that in 2006?
Make the answer very short. 1.69. What is the ratio of the Amount (in current US$) of Ghana in 2001 to that in 2002?
Offer a terse response. 1.54. What is the ratio of the Amount (in current US$) in Guyana in 2001 to that in 2002?
Keep it short and to the point. 1.94. What is the ratio of the Amount (in current US$) of Macedonia in 2001 to that in 2002?
Your answer should be compact. 0.45. What is the ratio of the Amount (in current US$) in Ghana in 2001 to that in 2003?
Keep it short and to the point. 0.82. What is the ratio of the Amount (in current US$) of Guyana in 2001 to that in 2003?
Keep it short and to the point. 0.93. What is the ratio of the Amount (in current US$) of Macedonia in 2001 to that in 2003?
Your answer should be very brief. 0.29. What is the ratio of the Amount (in current US$) of Ghana in 2001 to that in 2004?
Keep it short and to the point. 0.63. What is the ratio of the Amount (in current US$) of Guyana in 2001 to that in 2004?
Your response must be concise. 0.86. What is the ratio of the Amount (in current US$) in Macedonia in 2001 to that in 2004?
Offer a very short reply. 0.18. What is the ratio of the Amount (in current US$) in Ghana in 2001 to that in 2005?
Provide a short and direct response. 0.54. What is the ratio of the Amount (in current US$) of Guyana in 2001 to that in 2005?
Your response must be concise. 0.82. What is the ratio of the Amount (in current US$) in Macedonia in 2001 to that in 2005?
Give a very brief answer. 0.24. What is the ratio of the Amount (in current US$) of Ghana in 2001 to that in 2006?
Give a very brief answer. 0.67. What is the ratio of the Amount (in current US$) in Guyana in 2001 to that in 2006?
Give a very brief answer. 0.76. What is the ratio of the Amount (in current US$) in Macedonia in 2001 to that in 2006?
Offer a terse response. 0.42. What is the ratio of the Amount (in current US$) in Ghana in 2002 to that in 2003?
Make the answer very short. 0.53. What is the ratio of the Amount (in current US$) of Guyana in 2002 to that in 2003?
Provide a short and direct response. 0.48. What is the ratio of the Amount (in current US$) in Macedonia in 2002 to that in 2003?
Make the answer very short. 0.64. What is the ratio of the Amount (in current US$) of Ghana in 2002 to that in 2004?
Offer a terse response. 0.41. What is the ratio of the Amount (in current US$) of Guyana in 2002 to that in 2004?
Your answer should be very brief. 0.45. What is the ratio of the Amount (in current US$) in Macedonia in 2002 to that in 2004?
Keep it short and to the point. 0.4. What is the ratio of the Amount (in current US$) in Ghana in 2002 to that in 2005?
Provide a short and direct response. 0.35. What is the ratio of the Amount (in current US$) of Guyana in 2002 to that in 2005?
Offer a very short reply. 0.42. What is the ratio of the Amount (in current US$) in Macedonia in 2002 to that in 2005?
Offer a terse response. 0.52. What is the ratio of the Amount (in current US$) in Ghana in 2002 to that in 2006?
Provide a succinct answer. 0.43. What is the ratio of the Amount (in current US$) of Guyana in 2002 to that in 2006?
Offer a very short reply. 0.39. What is the ratio of the Amount (in current US$) in Macedonia in 2002 to that in 2006?
Offer a very short reply. 0.93. What is the ratio of the Amount (in current US$) in Ghana in 2003 to that in 2004?
Give a very brief answer. 0.77. What is the ratio of the Amount (in current US$) of Guyana in 2003 to that in 2004?
Keep it short and to the point. 0.92. What is the ratio of the Amount (in current US$) in Macedonia in 2003 to that in 2004?
Offer a terse response. 0.62. What is the ratio of the Amount (in current US$) of Ghana in 2003 to that in 2005?
Offer a terse response. 0.66. What is the ratio of the Amount (in current US$) in Guyana in 2003 to that in 2005?
Offer a very short reply. 0.88. What is the ratio of the Amount (in current US$) of Macedonia in 2003 to that in 2005?
Your answer should be very brief. 0.81. What is the ratio of the Amount (in current US$) in Ghana in 2003 to that in 2006?
Your answer should be very brief. 0.81. What is the ratio of the Amount (in current US$) in Guyana in 2003 to that in 2006?
Offer a terse response. 0.82. What is the ratio of the Amount (in current US$) of Macedonia in 2003 to that in 2006?
Your answer should be compact. 1.45. What is the ratio of the Amount (in current US$) in Ghana in 2004 to that in 2005?
Give a very brief answer. 0.86. What is the ratio of the Amount (in current US$) of Guyana in 2004 to that in 2005?
Your response must be concise. 0.95. What is the ratio of the Amount (in current US$) of Macedonia in 2004 to that in 2005?
Give a very brief answer. 1.31. What is the ratio of the Amount (in current US$) of Ghana in 2004 to that in 2006?
Ensure brevity in your answer.  1.06. What is the ratio of the Amount (in current US$) in Guyana in 2004 to that in 2006?
Your response must be concise. 0.88. What is the ratio of the Amount (in current US$) of Macedonia in 2004 to that in 2006?
Ensure brevity in your answer.  2.33. What is the ratio of the Amount (in current US$) in Ghana in 2005 to that in 2006?
Your answer should be compact. 1.23. What is the ratio of the Amount (in current US$) in Guyana in 2005 to that in 2006?
Your response must be concise. 0.93. What is the ratio of the Amount (in current US$) of Macedonia in 2005 to that in 2006?
Give a very brief answer. 1.78. What is the ratio of the Amount (in current US$) of Morocco in 2005 to that in 2006?
Offer a terse response. 1.01. What is the difference between the highest and the second highest Amount (in current US$) of Ghana?
Provide a short and direct response. 5.17e+07. What is the difference between the highest and the second highest Amount (in current US$) in Guyana?
Provide a succinct answer. 4.38e+06. What is the difference between the highest and the second highest Amount (in current US$) in Macedonia?
Provide a succinct answer. 1.78e+07. What is the difference between the highest and the second highest Amount (in current US$) of Morocco?
Ensure brevity in your answer.  6.27e+06. What is the difference between the highest and the lowest Amount (in current US$) of Ghana?
Provide a succinct answer. 2.34e+08. What is the difference between the highest and the lowest Amount (in current US$) in Guyana?
Your answer should be compact. 3.88e+07. What is the difference between the highest and the lowest Amount (in current US$) of Macedonia?
Ensure brevity in your answer.  8.48e+07. What is the difference between the highest and the lowest Amount (in current US$) of Morocco?
Your response must be concise. 4.45e+08. 